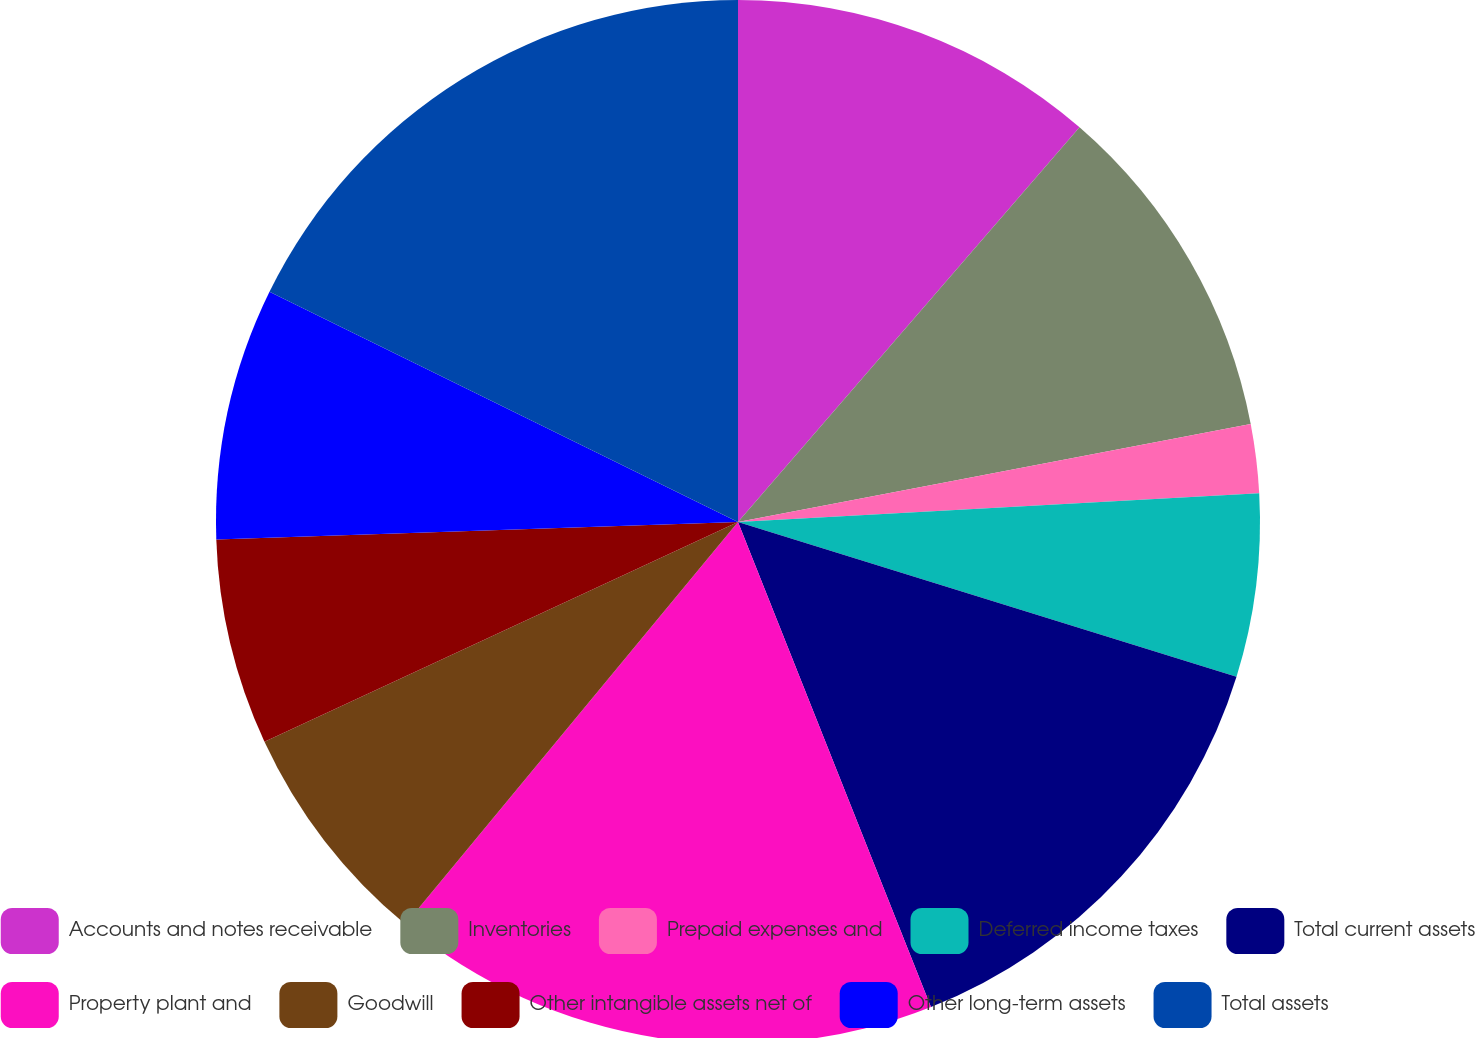Convert chart. <chart><loc_0><loc_0><loc_500><loc_500><pie_chart><fcel>Accounts and notes receivable<fcel>Inventories<fcel>Prepaid expenses and<fcel>Deferred income taxes<fcel>Total current assets<fcel>Property plant and<fcel>Goodwill<fcel>Other intangible assets net of<fcel>Other long-term assets<fcel>Total assets<nl><fcel>11.35%<fcel>10.64%<fcel>2.13%<fcel>5.67%<fcel>14.18%<fcel>17.02%<fcel>7.09%<fcel>6.38%<fcel>7.8%<fcel>17.73%<nl></chart> 